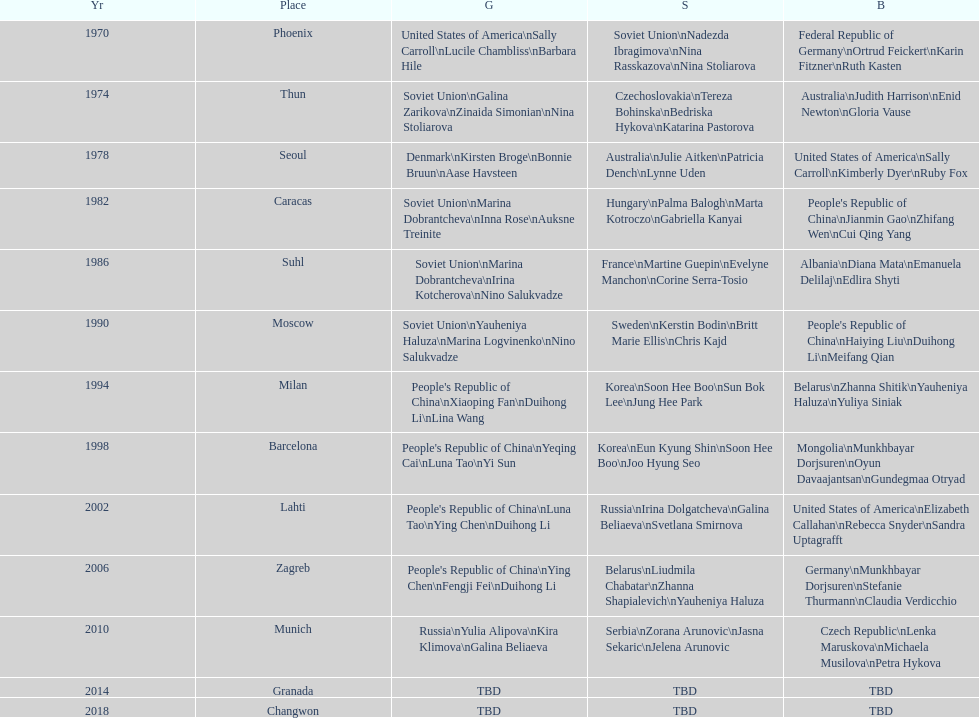How many world championships had the soviet union won first place in in the 25 metre pistol women's world championship? 4. 